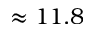Convert formula to latex. <formula><loc_0><loc_0><loc_500><loc_500>\approx 1 1 . 8</formula> 